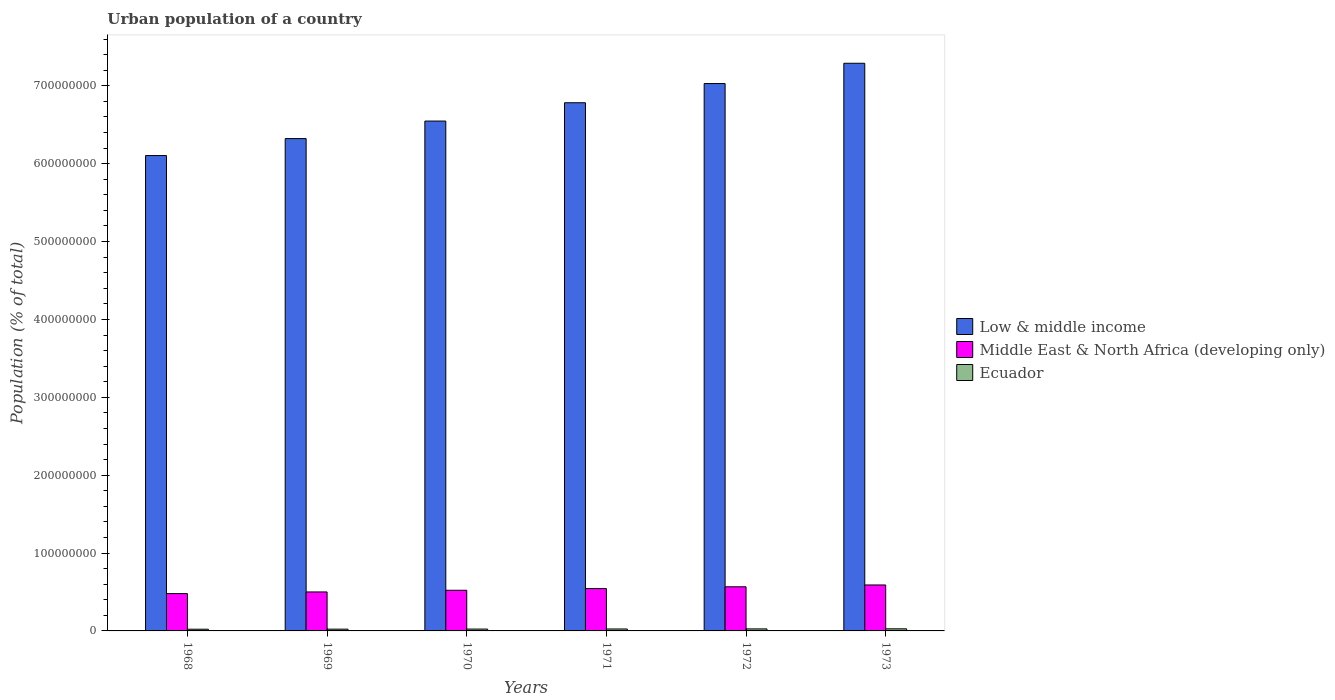How many different coloured bars are there?
Provide a short and direct response. 3. How many bars are there on the 3rd tick from the left?
Your response must be concise. 3. How many bars are there on the 2nd tick from the right?
Your answer should be compact. 3. What is the label of the 1st group of bars from the left?
Give a very brief answer. 1968. What is the urban population in Low & middle income in 1972?
Give a very brief answer. 7.03e+08. Across all years, what is the maximum urban population in Middle East & North Africa (developing only)?
Keep it short and to the point. 5.90e+07. Across all years, what is the minimum urban population in Ecuador?
Ensure brevity in your answer.  2.19e+06. In which year was the urban population in Low & middle income minimum?
Your response must be concise. 1968. What is the total urban population in Middle East & North Africa (developing only) in the graph?
Offer a terse response. 3.20e+08. What is the difference between the urban population in Low & middle income in 1969 and that in 1971?
Make the answer very short. -4.60e+07. What is the difference between the urban population in Middle East & North Africa (developing only) in 1968 and the urban population in Low & middle income in 1970?
Keep it short and to the point. -6.07e+08. What is the average urban population in Middle East & North Africa (developing only) per year?
Offer a terse response. 5.34e+07. In the year 1971, what is the difference between the urban population in Middle East & North Africa (developing only) and urban population in Ecuador?
Provide a short and direct response. 5.19e+07. In how many years, is the urban population in Low & middle income greater than 420000000 %?
Offer a very short reply. 6. What is the ratio of the urban population in Low & middle income in 1972 to that in 1973?
Offer a very short reply. 0.96. Is the difference between the urban population in Middle East & North Africa (developing only) in 1969 and 1972 greater than the difference between the urban population in Ecuador in 1969 and 1972?
Keep it short and to the point. No. What is the difference between the highest and the second highest urban population in Low & middle income?
Offer a very short reply. 2.61e+07. What is the difference between the highest and the lowest urban population in Low & middle income?
Your response must be concise. 1.19e+08. Is the sum of the urban population in Middle East & North Africa (developing only) in 1969 and 1972 greater than the maximum urban population in Ecuador across all years?
Your answer should be very brief. Yes. What does the 2nd bar from the left in 1970 represents?
Offer a terse response. Middle East & North Africa (developing only). What does the 2nd bar from the right in 1972 represents?
Keep it short and to the point. Middle East & North Africa (developing only). Is it the case that in every year, the sum of the urban population in Low & middle income and urban population in Middle East & North Africa (developing only) is greater than the urban population in Ecuador?
Offer a terse response. Yes. How many bars are there?
Offer a very short reply. 18. Are all the bars in the graph horizontal?
Offer a terse response. No. How many years are there in the graph?
Give a very brief answer. 6. What is the difference between two consecutive major ticks on the Y-axis?
Make the answer very short. 1.00e+08. Does the graph contain any zero values?
Your answer should be compact. No. Where does the legend appear in the graph?
Your response must be concise. Center right. How many legend labels are there?
Keep it short and to the point. 3. How are the legend labels stacked?
Keep it short and to the point. Vertical. What is the title of the graph?
Your answer should be compact. Urban population of a country. What is the label or title of the Y-axis?
Your response must be concise. Population (% of total). What is the Population (% of total) in Low & middle income in 1968?
Offer a very short reply. 6.10e+08. What is the Population (% of total) of Middle East & North Africa (developing only) in 1968?
Make the answer very short. 4.79e+07. What is the Population (% of total) in Ecuador in 1968?
Your answer should be very brief. 2.19e+06. What is the Population (% of total) in Low & middle income in 1969?
Provide a succinct answer. 6.32e+08. What is the Population (% of total) of Middle East & North Africa (developing only) in 1969?
Ensure brevity in your answer.  5.00e+07. What is the Population (% of total) in Ecuador in 1969?
Provide a succinct answer. 2.29e+06. What is the Population (% of total) in Low & middle income in 1970?
Your answer should be compact. 6.55e+08. What is the Population (% of total) in Middle East & North Africa (developing only) in 1970?
Make the answer very short. 5.22e+07. What is the Population (% of total) in Ecuador in 1970?
Your response must be concise. 2.39e+06. What is the Population (% of total) in Low & middle income in 1971?
Keep it short and to the point. 6.78e+08. What is the Population (% of total) in Middle East & North Africa (developing only) in 1971?
Offer a terse response. 5.44e+07. What is the Population (% of total) of Ecuador in 1971?
Provide a succinct answer. 2.49e+06. What is the Population (% of total) of Low & middle income in 1972?
Ensure brevity in your answer.  7.03e+08. What is the Population (% of total) of Middle East & North Africa (developing only) in 1972?
Your response must be concise. 5.67e+07. What is the Population (% of total) in Ecuador in 1972?
Your answer should be very brief. 2.59e+06. What is the Population (% of total) in Low & middle income in 1973?
Provide a succinct answer. 7.29e+08. What is the Population (% of total) of Middle East & North Africa (developing only) in 1973?
Offer a very short reply. 5.90e+07. What is the Population (% of total) in Ecuador in 1973?
Ensure brevity in your answer.  2.70e+06. Across all years, what is the maximum Population (% of total) of Low & middle income?
Your answer should be compact. 7.29e+08. Across all years, what is the maximum Population (% of total) of Middle East & North Africa (developing only)?
Offer a very short reply. 5.90e+07. Across all years, what is the maximum Population (% of total) in Ecuador?
Keep it short and to the point. 2.70e+06. Across all years, what is the minimum Population (% of total) in Low & middle income?
Your answer should be very brief. 6.10e+08. Across all years, what is the minimum Population (% of total) of Middle East & North Africa (developing only)?
Your response must be concise. 4.79e+07. Across all years, what is the minimum Population (% of total) of Ecuador?
Your answer should be compact. 2.19e+06. What is the total Population (% of total) of Low & middle income in the graph?
Your response must be concise. 4.01e+09. What is the total Population (% of total) in Middle East & North Africa (developing only) in the graph?
Keep it short and to the point. 3.20e+08. What is the total Population (% of total) in Ecuador in the graph?
Your answer should be compact. 1.46e+07. What is the difference between the Population (% of total) of Low & middle income in 1968 and that in 1969?
Make the answer very short. -2.18e+07. What is the difference between the Population (% of total) in Middle East & North Africa (developing only) in 1968 and that in 1969?
Make the answer very short. -2.10e+06. What is the difference between the Population (% of total) in Ecuador in 1968 and that in 1969?
Make the answer very short. -9.58e+04. What is the difference between the Population (% of total) in Low & middle income in 1968 and that in 1970?
Your response must be concise. -4.43e+07. What is the difference between the Population (% of total) in Middle East & North Africa (developing only) in 1968 and that in 1970?
Your answer should be compact. -4.27e+06. What is the difference between the Population (% of total) of Ecuador in 1968 and that in 1970?
Provide a short and direct response. -1.95e+05. What is the difference between the Population (% of total) in Low & middle income in 1968 and that in 1971?
Give a very brief answer. -6.78e+07. What is the difference between the Population (% of total) in Middle East & North Africa (developing only) in 1968 and that in 1971?
Your answer should be very brief. -6.46e+06. What is the difference between the Population (% of total) in Ecuador in 1968 and that in 1971?
Give a very brief answer. -2.98e+05. What is the difference between the Population (% of total) in Low & middle income in 1968 and that in 1972?
Your answer should be compact. -9.25e+07. What is the difference between the Population (% of total) in Middle East & North Africa (developing only) in 1968 and that in 1972?
Ensure brevity in your answer.  -8.73e+06. What is the difference between the Population (% of total) of Ecuador in 1968 and that in 1972?
Offer a very short reply. -4.04e+05. What is the difference between the Population (% of total) of Low & middle income in 1968 and that in 1973?
Provide a succinct answer. -1.19e+08. What is the difference between the Population (% of total) of Middle East & North Africa (developing only) in 1968 and that in 1973?
Ensure brevity in your answer.  -1.11e+07. What is the difference between the Population (% of total) of Ecuador in 1968 and that in 1973?
Offer a very short reply. -5.14e+05. What is the difference between the Population (% of total) in Low & middle income in 1969 and that in 1970?
Ensure brevity in your answer.  -2.25e+07. What is the difference between the Population (% of total) of Middle East & North Africa (developing only) in 1969 and that in 1970?
Your answer should be very brief. -2.16e+06. What is the difference between the Population (% of total) in Ecuador in 1969 and that in 1970?
Offer a very short reply. -9.93e+04. What is the difference between the Population (% of total) of Low & middle income in 1969 and that in 1971?
Offer a terse response. -4.60e+07. What is the difference between the Population (% of total) in Middle East & North Africa (developing only) in 1969 and that in 1971?
Give a very brief answer. -4.35e+06. What is the difference between the Population (% of total) of Ecuador in 1969 and that in 1971?
Provide a short and direct response. -2.02e+05. What is the difference between the Population (% of total) in Low & middle income in 1969 and that in 1972?
Offer a terse response. -7.07e+07. What is the difference between the Population (% of total) of Middle East & North Africa (developing only) in 1969 and that in 1972?
Give a very brief answer. -6.62e+06. What is the difference between the Population (% of total) in Ecuador in 1969 and that in 1972?
Offer a very short reply. -3.08e+05. What is the difference between the Population (% of total) of Low & middle income in 1969 and that in 1973?
Ensure brevity in your answer.  -9.67e+07. What is the difference between the Population (% of total) of Middle East & North Africa (developing only) in 1969 and that in 1973?
Provide a succinct answer. -8.98e+06. What is the difference between the Population (% of total) in Ecuador in 1969 and that in 1973?
Offer a very short reply. -4.18e+05. What is the difference between the Population (% of total) of Low & middle income in 1970 and that in 1971?
Your answer should be compact. -2.35e+07. What is the difference between the Population (% of total) in Middle East & North Africa (developing only) in 1970 and that in 1971?
Ensure brevity in your answer.  -2.19e+06. What is the difference between the Population (% of total) of Ecuador in 1970 and that in 1971?
Offer a very short reply. -1.03e+05. What is the difference between the Population (% of total) in Low & middle income in 1970 and that in 1972?
Offer a very short reply. -4.82e+07. What is the difference between the Population (% of total) of Middle East & North Africa (developing only) in 1970 and that in 1972?
Keep it short and to the point. -4.46e+06. What is the difference between the Population (% of total) in Ecuador in 1970 and that in 1972?
Your response must be concise. -2.09e+05. What is the difference between the Population (% of total) in Low & middle income in 1970 and that in 1973?
Ensure brevity in your answer.  -7.42e+07. What is the difference between the Population (% of total) in Middle East & North Africa (developing only) in 1970 and that in 1973?
Your answer should be very brief. -6.81e+06. What is the difference between the Population (% of total) of Ecuador in 1970 and that in 1973?
Provide a succinct answer. -3.19e+05. What is the difference between the Population (% of total) of Low & middle income in 1971 and that in 1972?
Make the answer very short. -2.46e+07. What is the difference between the Population (% of total) of Middle East & North Africa (developing only) in 1971 and that in 1972?
Your answer should be compact. -2.27e+06. What is the difference between the Population (% of total) in Ecuador in 1971 and that in 1972?
Ensure brevity in your answer.  -1.06e+05. What is the difference between the Population (% of total) of Low & middle income in 1971 and that in 1973?
Offer a very short reply. -5.07e+07. What is the difference between the Population (% of total) in Middle East & North Africa (developing only) in 1971 and that in 1973?
Give a very brief answer. -4.62e+06. What is the difference between the Population (% of total) in Ecuador in 1971 and that in 1973?
Keep it short and to the point. -2.16e+05. What is the difference between the Population (% of total) of Low & middle income in 1972 and that in 1973?
Your answer should be very brief. -2.61e+07. What is the difference between the Population (% of total) in Middle East & North Africa (developing only) in 1972 and that in 1973?
Your answer should be very brief. -2.35e+06. What is the difference between the Population (% of total) in Ecuador in 1972 and that in 1973?
Provide a short and direct response. -1.10e+05. What is the difference between the Population (% of total) of Low & middle income in 1968 and the Population (% of total) of Middle East & North Africa (developing only) in 1969?
Provide a succinct answer. 5.60e+08. What is the difference between the Population (% of total) of Low & middle income in 1968 and the Population (% of total) of Ecuador in 1969?
Your answer should be very brief. 6.08e+08. What is the difference between the Population (% of total) of Middle East & North Africa (developing only) in 1968 and the Population (% of total) of Ecuador in 1969?
Provide a succinct answer. 4.57e+07. What is the difference between the Population (% of total) of Low & middle income in 1968 and the Population (% of total) of Middle East & North Africa (developing only) in 1970?
Provide a succinct answer. 5.58e+08. What is the difference between the Population (% of total) in Low & middle income in 1968 and the Population (% of total) in Ecuador in 1970?
Keep it short and to the point. 6.08e+08. What is the difference between the Population (% of total) in Middle East & North Africa (developing only) in 1968 and the Population (% of total) in Ecuador in 1970?
Ensure brevity in your answer.  4.56e+07. What is the difference between the Population (% of total) in Low & middle income in 1968 and the Population (% of total) in Middle East & North Africa (developing only) in 1971?
Offer a very short reply. 5.56e+08. What is the difference between the Population (% of total) in Low & middle income in 1968 and the Population (% of total) in Ecuador in 1971?
Provide a short and direct response. 6.08e+08. What is the difference between the Population (% of total) in Middle East & North Africa (developing only) in 1968 and the Population (% of total) in Ecuador in 1971?
Make the answer very short. 4.55e+07. What is the difference between the Population (% of total) in Low & middle income in 1968 and the Population (% of total) in Middle East & North Africa (developing only) in 1972?
Keep it short and to the point. 5.54e+08. What is the difference between the Population (% of total) of Low & middle income in 1968 and the Population (% of total) of Ecuador in 1972?
Provide a short and direct response. 6.08e+08. What is the difference between the Population (% of total) in Middle East & North Africa (developing only) in 1968 and the Population (% of total) in Ecuador in 1972?
Offer a terse response. 4.53e+07. What is the difference between the Population (% of total) of Low & middle income in 1968 and the Population (% of total) of Middle East & North Africa (developing only) in 1973?
Your answer should be compact. 5.51e+08. What is the difference between the Population (% of total) in Low & middle income in 1968 and the Population (% of total) in Ecuador in 1973?
Give a very brief answer. 6.08e+08. What is the difference between the Population (% of total) in Middle East & North Africa (developing only) in 1968 and the Population (% of total) in Ecuador in 1973?
Give a very brief answer. 4.52e+07. What is the difference between the Population (% of total) in Low & middle income in 1969 and the Population (% of total) in Middle East & North Africa (developing only) in 1970?
Provide a short and direct response. 5.80e+08. What is the difference between the Population (% of total) in Low & middle income in 1969 and the Population (% of total) in Ecuador in 1970?
Your response must be concise. 6.30e+08. What is the difference between the Population (% of total) of Middle East & North Africa (developing only) in 1969 and the Population (% of total) of Ecuador in 1970?
Your answer should be very brief. 4.77e+07. What is the difference between the Population (% of total) in Low & middle income in 1969 and the Population (% of total) in Middle East & North Africa (developing only) in 1971?
Make the answer very short. 5.78e+08. What is the difference between the Population (% of total) of Low & middle income in 1969 and the Population (% of total) of Ecuador in 1971?
Give a very brief answer. 6.30e+08. What is the difference between the Population (% of total) in Middle East & North Africa (developing only) in 1969 and the Population (% of total) in Ecuador in 1971?
Ensure brevity in your answer.  4.76e+07. What is the difference between the Population (% of total) of Low & middle income in 1969 and the Population (% of total) of Middle East & North Africa (developing only) in 1972?
Keep it short and to the point. 5.76e+08. What is the difference between the Population (% of total) in Low & middle income in 1969 and the Population (% of total) in Ecuador in 1972?
Offer a terse response. 6.30e+08. What is the difference between the Population (% of total) of Middle East & North Africa (developing only) in 1969 and the Population (% of total) of Ecuador in 1972?
Your answer should be compact. 4.74e+07. What is the difference between the Population (% of total) of Low & middle income in 1969 and the Population (% of total) of Middle East & North Africa (developing only) in 1973?
Provide a short and direct response. 5.73e+08. What is the difference between the Population (% of total) in Low & middle income in 1969 and the Population (% of total) in Ecuador in 1973?
Provide a short and direct response. 6.30e+08. What is the difference between the Population (% of total) of Middle East & North Africa (developing only) in 1969 and the Population (% of total) of Ecuador in 1973?
Ensure brevity in your answer.  4.73e+07. What is the difference between the Population (% of total) in Low & middle income in 1970 and the Population (% of total) in Middle East & North Africa (developing only) in 1971?
Give a very brief answer. 6.00e+08. What is the difference between the Population (% of total) in Low & middle income in 1970 and the Population (% of total) in Ecuador in 1971?
Give a very brief answer. 6.52e+08. What is the difference between the Population (% of total) in Middle East & North Africa (developing only) in 1970 and the Population (% of total) in Ecuador in 1971?
Keep it short and to the point. 4.97e+07. What is the difference between the Population (% of total) of Low & middle income in 1970 and the Population (% of total) of Middle East & North Africa (developing only) in 1972?
Your answer should be compact. 5.98e+08. What is the difference between the Population (% of total) of Low & middle income in 1970 and the Population (% of total) of Ecuador in 1972?
Ensure brevity in your answer.  6.52e+08. What is the difference between the Population (% of total) of Middle East & North Africa (developing only) in 1970 and the Population (% of total) of Ecuador in 1972?
Provide a short and direct response. 4.96e+07. What is the difference between the Population (% of total) in Low & middle income in 1970 and the Population (% of total) in Middle East & North Africa (developing only) in 1973?
Your response must be concise. 5.96e+08. What is the difference between the Population (% of total) of Low & middle income in 1970 and the Population (% of total) of Ecuador in 1973?
Make the answer very short. 6.52e+08. What is the difference between the Population (% of total) in Middle East & North Africa (developing only) in 1970 and the Population (% of total) in Ecuador in 1973?
Keep it short and to the point. 4.95e+07. What is the difference between the Population (% of total) in Low & middle income in 1971 and the Population (% of total) in Middle East & North Africa (developing only) in 1972?
Give a very brief answer. 6.22e+08. What is the difference between the Population (% of total) in Low & middle income in 1971 and the Population (% of total) in Ecuador in 1972?
Keep it short and to the point. 6.76e+08. What is the difference between the Population (% of total) in Middle East & North Africa (developing only) in 1971 and the Population (% of total) in Ecuador in 1972?
Keep it short and to the point. 5.18e+07. What is the difference between the Population (% of total) in Low & middle income in 1971 and the Population (% of total) in Middle East & North Africa (developing only) in 1973?
Keep it short and to the point. 6.19e+08. What is the difference between the Population (% of total) of Low & middle income in 1971 and the Population (% of total) of Ecuador in 1973?
Your response must be concise. 6.76e+08. What is the difference between the Population (% of total) in Middle East & North Africa (developing only) in 1971 and the Population (% of total) in Ecuador in 1973?
Your response must be concise. 5.17e+07. What is the difference between the Population (% of total) in Low & middle income in 1972 and the Population (% of total) in Middle East & North Africa (developing only) in 1973?
Your answer should be very brief. 6.44e+08. What is the difference between the Population (% of total) of Low & middle income in 1972 and the Population (% of total) of Ecuador in 1973?
Ensure brevity in your answer.  7.00e+08. What is the difference between the Population (% of total) in Middle East & North Africa (developing only) in 1972 and the Population (% of total) in Ecuador in 1973?
Provide a short and direct response. 5.40e+07. What is the average Population (% of total) in Low & middle income per year?
Make the answer very short. 6.68e+08. What is the average Population (% of total) in Middle East & North Africa (developing only) per year?
Keep it short and to the point. 5.34e+07. What is the average Population (% of total) in Ecuador per year?
Make the answer very short. 2.44e+06. In the year 1968, what is the difference between the Population (% of total) of Low & middle income and Population (% of total) of Middle East & North Africa (developing only)?
Your answer should be very brief. 5.63e+08. In the year 1968, what is the difference between the Population (% of total) in Low & middle income and Population (% of total) in Ecuador?
Provide a short and direct response. 6.08e+08. In the year 1968, what is the difference between the Population (% of total) in Middle East & North Africa (developing only) and Population (% of total) in Ecuador?
Offer a very short reply. 4.57e+07. In the year 1969, what is the difference between the Population (% of total) in Low & middle income and Population (% of total) in Middle East & North Africa (developing only)?
Provide a succinct answer. 5.82e+08. In the year 1969, what is the difference between the Population (% of total) in Low & middle income and Population (% of total) in Ecuador?
Your answer should be very brief. 6.30e+08. In the year 1969, what is the difference between the Population (% of total) in Middle East & North Africa (developing only) and Population (% of total) in Ecuador?
Offer a very short reply. 4.78e+07. In the year 1970, what is the difference between the Population (% of total) of Low & middle income and Population (% of total) of Middle East & North Africa (developing only)?
Your answer should be very brief. 6.03e+08. In the year 1970, what is the difference between the Population (% of total) of Low & middle income and Population (% of total) of Ecuador?
Your response must be concise. 6.52e+08. In the year 1970, what is the difference between the Population (% of total) in Middle East & North Africa (developing only) and Population (% of total) in Ecuador?
Give a very brief answer. 4.98e+07. In the year 1971, what is the difference between the Population (% of total) of Low & middle income and Population (% of total) of Middle East & North Africa (developing only)?
Give a very brief answer. 6.24e+08. In the year 1971, what is the difference between the Population (% of total) in Low & middle income and Population (% of total) in Ecuador?
Keep it short and to the point. 6.76e+08. In the year 1971, what is the difference between the Population (% of total) of Middle East & North Africa (developing only) and Population (% of total) of Ecuador?
Your response must be concise. 5.19e+07. In the year 1972, what is the difference between the Population (% of total) in Low & middle income and Population (% of total) in Middle East & North Africa (developing only)?
Make the answer very short. 6.46e+08. In the year 1972, what is the difference between the Population (% of total) of Low & middle income and Population (% of total) of Ecuador?
Give a very brief answer. 7.00e+08. In the year 1972, what is the difference between the Population (% of total) of Middle East & North Africa (developing only) and Population (% of total) of Ecuador?
Give a very brief answer. 5.41e+07. In the year 1973, what is the difference between the Population (% of total) of Low & middle income and Population (% of total) of Middle East & North Africa (developing only)?
Offer a very short reply. 6.70e+08. In the year 1973, what is the difference between the Population (% of total) of Low & middle income and Population (% of total) of Ecuador?
Provide a succinct answer. 7.26e+08. In the year 1973, what is the difference between the Population (% of total) in Middle East & North Africa (developing only) and Population (% of total) in Ecuador?
Give a very brief answer. 5.63e+07. What is the ratio of the Population (% of total) in Low & middle income in 1968 to that in 1969?
Your answer should be compact. 0.97. What is the ratio of the Population (% of total) of Middle East & North Africa (developing only) in 1968 to that in 1969?
Give a very brief answer. 0.96. What is the ratio of the Population (% of total) in Ecuador in 1968 to that in 1969?
Offer a very short reply. 0.96. What is the ratio of the Population (% of total) of Low & middle income in 1968 to that in 1970?
Ensure brevity in your answer.  0.93. What is the ratio of the Population (% of total) of Middle East & North Africa (developing only) in 1968 to that in 1970?
Ensure brevity in your answer.  0.92. What is the ratio of the Population (% of total) in Ecuador in 1968 to that in 1970?
Your response must be concise. 0.92. What is the ratio of the Population (% of total) of Middle East & North Africa (developing only) in 1968 to that in 1971?
Give a very brief answer. 0.88. What is the ratio of the Population (% of total) in Ecuador in 1968 to that in 1971?
Your response must be concise. 0.88. What is the ratio of the Population (% of total) in Low & middle income in 1968 to that in 1972?
Provide a short and direct response. 0.87. What is the ratio of the Population (% of total) of Middle East & North Africa (developing only) in 1968 to that in 1972?
Offer a terse response. 0.85. What is the ratio of the Population (% of total) in Ecuador in 1968 to that in 1972?
Your response must be concise. 0.84. What is the ratio of the Population (% of total) in Low & middle income in 1968 to that in 1973?
Offer a very short reply. 0.84. What is the ratio of the Population (% of total) of Middle East & North Africa (developing only) in 1968 to that in 1973?
Provide a short and direct response. 0.81. What is the ratio of the Population (% of total) in Ecuador in 1968 to that in 1973?
Offer a very short reply. 0.81. What is the ratio of the Population (% of total) in Low & middle income in 1969 to that in 1970?
Ensure brevity in your answer.  0.97. What is the ratio of the Population (% of total) of Middle East & North Africa (developing only) in 1969 to that in 1970?
Your answer should be compact. 0.96. What is the ratio of the Population (% of total) of Ecuador in 1969 to that in 1970?
Your answer should be very brief. 0.96. What is the ratio of the Population (% of total) of Low & middle income in 1969 to that in 1971?
Offer a terse response. 0.93. What is the ratio of the Population (% of total) in Ecuador in 1969 to that in 1971?
Your answer should be compact. 0.92. What is the ratio of the Population (% of total) of Low & middle income in 1969 to that in 1972?
Offer a very short reply. 0.9. What is the ratio of the Population (% of total) in Middle East & North Africa (developing only) in 1969 to that in 1972?
Give a very brief answer. 0.88. What is the ratio of the Population (% of total) in Ecuador in 1969 to that in 1972?
Offer a terse response. 0.88. What is the ratio of the Population (% of total) in Low & middle income in 1969 to that in 1973?
Your response must be concise. 0.87. What is the ratio of the Population (% of total) in Middle East & North Africa (developing only) in 1969 to that in 1973?
Your response must be concise. 0.85. What is the ratio of the Population (% of total) of Ecuador in 1969 to that in 1973?
Offer a terse response. 0.85. What is the ratio of the Population (% of total) in Low & middle income in 1970 to that in 1971?
Give a very brief answer. 0.97. What is the ratio of the Population (% of total) of Middle East & North Africa (developing only) in 1970 to that in 1971?
Your response must be concise. 0.96. What is the ratio of the Population (% of total) of Ecuador in 1970 to that in 1971?
Give a very brief answer. 0.96. What is the ratio of the Population (% of total) in Low & middle income in 1970 to that in 1972?
Make the answer very short. 0.93. What is the ratio of the Population (% of total) in Middle East & North Africa (developing only) in 1970 to that in 1972?
Keep it short and to the point. 0.92. What is the ratio of the Population (% of total) of Ecuador in 1970 to that in 1972?
Your response must be concise. 0.92. What is the ratio of the Population (% of total) in Low & middle income in 1970 to that in 1973?
Make the answer very short. 0.9. What is the ratio of the Population (% of total) of Middle East & North Africa (developing only) in 1970 to that in 1973?
Provide a succinct answer. 0.88. What is the ratio of the Population (% of total) of Ecuador in 1970 to that in 1973?
Give a very brief answer. 0.88. What is the ratio of the Population (% of total) of Low & middle income in 1971 to that in 1972?
Provide a short and direct response. 0.96. What is the ratio of the Population (% of total) in Middle East & North Africa (developing only) in 1971 to that in 1972?
Offer a very short reply. 0.96. What is the ratio of the Population (% of total) of Ecuador in 1971 to that in 1972?
Provide a short and direct response. 0.96. What is the ratio of the Population (% of total) of Low & middle income in 1971 to that in 1973?
Your answer should be very brief. 0.93. What is the ratio of the Population (% of total) in Middle East & North Africa (developing only) in 1971 to that in 1973?
Give a very brief answer. 0.92. What is the ratio of the Population (% of total) in Ecuador in 1971 to that in 1973?
Your response must be concise. 0.92. What is the ratio of the Population (% of total) in Low & middle income in 1972 to that in 1973?
Provide a succinct answer. 0.96. What is the ratio of the Population (% of total) in Middle East & North Africa (developing only) in 1972 to that in 1973?
Make the answer very short. 0.96. What is the ratio of the Population (% of total) in Ecuador in 1972 to that in 1973?
Offer a very short reply. 0.96. What is the difference between the highest and the second highest Population (% of total) of Low & middle income?
Keep it short and to the point. 2.61e+07. What is the difference between the highest and the second highest Population (% of total) of Middle East & North Africa (developing only)?
Ensure brevity in your answer.  2.35e+06. What is the difference between the highest and the second highest Population (% of total) in Ecuador?
Give a very brief answer. 1.10e+05. What is the difference between the highest and the lowest Population (% of total) in Low & middle income?
Your response must be concise. 1.19e+08. What is the difference between the highest and the lowest Population (% of total) in Middle East & North Africa (developing only)?
Provide a short and direct response. 1.11e+07. What is the difference between the highest and the lowest Population (% of total) in Ecuador?
Offer a very short reply. 5.14e+05. 